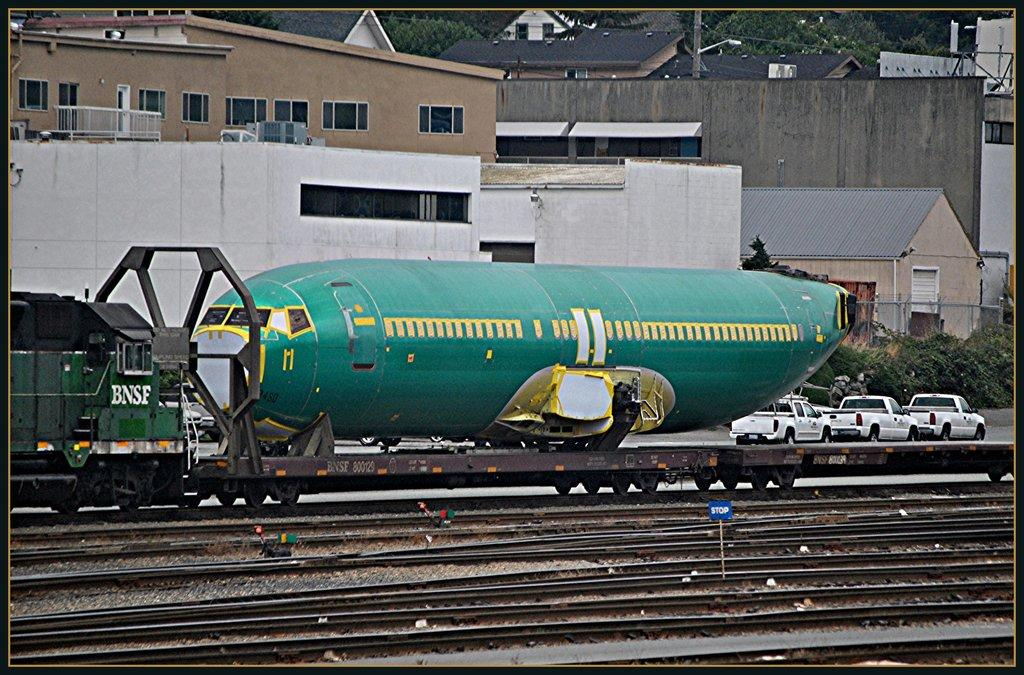<image>
Provide a brief description of the given image. the train pulling the airplane is green and has the letters BNSF painted on it 